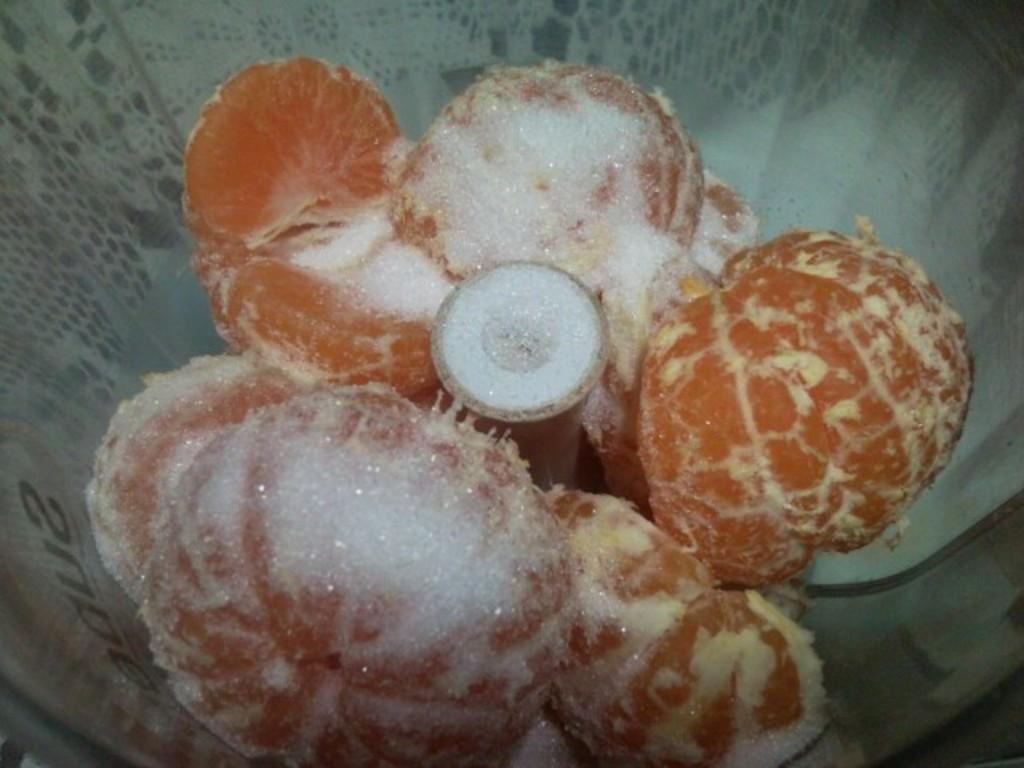What type of fruit is present in the image? There are oranges in the image. What is the oranges being used for in the image? The image does not provide information about the use of the oranges. What is the other item visible in the image? There is sugar in the image. What is the color of the white object in the image? The white object in the image is white. How many crates are visible in the image? There are no crates present in the image. What type of game is being played in the image? There is no game or play activity depicted in the image. 